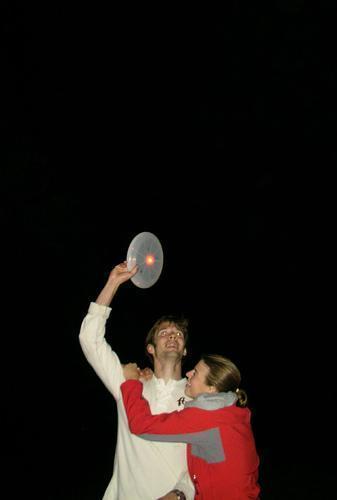How many people are in the scene?
Give a very brief answer. 2. How many people are there?
Give a very brief answer. 2. How many of the pizzas have green vegetables?
Give a very brief answer. 0. 